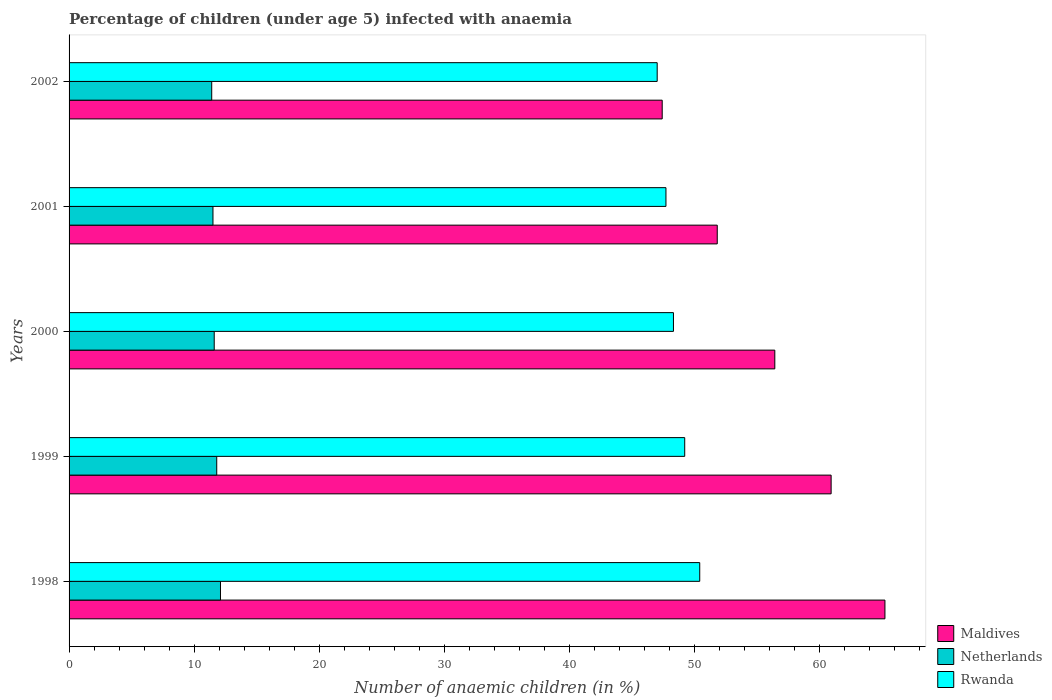How many groups of bars are there?
Your answer should be very brief. 5. How many bars are there on the 1st tick from the bottom?
Make the answer very short. 3. What is the label of the 5th group of bars from the top?
Give a very brief answer. 1998. In how many cases, is the number of bars for a given year not equal to the number of legend labels?
Your response must be concise. 0. Across all years, what is the maximum percentage of children infected with anaemia in in Maldives?
Ensure brevity in your answer.  65.2. Across all years, what is the minimum percentage of children infected with anaemia in in Netherlands?
Your response must be concise. 11.4. In which year was the percentage of children infected with anaemia in in Rwanda minimum?
Ensure brevity in your answer.  2002. What is the total percentage of children infected with anaemia in in Maldives in the graph?
Make the answer very short. 281.7. What is the difference between the percentage of children infected with anaemia in in Maldives in 1998 and that in 1999?
Provide a succinct answer. 4.3. What is the difference between the percentage of children infected with anaemia in in Rwanda in 2000 and the percentage of children infected with anaemia in in Netherlands in 2001?
Offer a very short reply. 36.8. What is the average percentage of children infected with anaemia in in Netherlands per year?
Your response must be concise. 11.68. In the year 1998, what is the difference between the percentage of children infected with anaemia in in Maldives and percentage of children infected with anaemia in in Rwanda?
Provide a succinct answer. 14.8. In how many years, is the percentage of children infected with anaemia in in Rwanda greater than 32 %?
Your response must be concise. 5. What is the ratio of the percentage of children infected with anaemia in in Rwanda in 1998 to that in 2002?
Ensure brevity in your answer.  1.07. What is the difference between the highest and the second highest percentage of children infected with anaemia in in Rwanda?
Keep it short and to the point. 1.2. What is the difference between the highest and the lowest percentage of children infected with anaemia in in Netherlands?
Offer a very short reply. 0.7. In how many years, is the percentage of children infected with anaemia in in Netherlands greater than the average percentage of children infected with anaemia in in Netherlands taken over all years?
Your response must be concise. 2. What does the 3rd bar from the top in 1999 represents?
Offer a terse response. Maldives. What does the 3rd bar from the bottom in 1998 represents?
Provide a short and direct response. Rwanda. How many bars are there?
Make the answer very short. 15. What is the difference between two consecutive major ticks on the X-axis?
Ensure brevity in your answer.  10. Are the values on the major ticks of X-axis written in scientific E-notation?
Your response must be concise. No. Does the graph contain any zero values?
Keep it short and to the point. No. Where does the legend appear in the graph?
Your response must be concise. Bottom right. How are the legend labels stacked?
Make the answer very short. Vertical. What is the title of the graph?
Offer a terse response. Percentage of children (under age 5) infected with anaemia. Does "Mauritania" appear as one of the legend labels in the graph?
Your answer should be very brief. No. What is the label or title of the X-axis?
Your answer should be compact. Number of anaemic children (in %). What is the Number of anaemic children (in %) in Maldives in 1998?
Offer a very short reply. 65.2. What is the Number of anaemic children (in %) in Netherlands in 1998?
Ensure brevity in your answer.  12.1. What is the Number of anaemic children (in %) of Rwanda in 1998?
Your response must be concise. 50.4. What is the Number of anaemic children (in %) in Maldives in 1999?
Your answer should be compact. 60.9. What is the Number of anaemic children (in %) of Rwanda in 1999?
Make the answer very short. 49.2. What is the Number of anaemic children (in %) in Maldives in 2000?
Offer a terse response. 56.4. What is the Number of anaemic children (in %) of Rwanda in 2000?
Your answer should be compact. 48.3. What is the Number of anaemic children (in %) of Maldives in 2001?
Your response must be concise. 51.8. What is the Number of anaemic children (in %) in Netherlands in 2001?
Provide a short and direct response. 11.5. What is the Number of anaemic children (in %) of Rwanda in 2001?
Give a very brief answer. 47.7. What is the Number of anaemic children (in %) in Maldives in 2002?
Ensure brevity in your answer.  47.4. What is the Number of anaemic children (in %) of Netherlands in 2002?
Your response must be concise. 11.4. Across all years, what is the maximum Number of anaemic children (in %) in Maldives?
Keep it short and to the point. 65.2. Across all years, what is the maximum Number of anaemic children (in %) in Netherlands?
Provide a short and direct response. 12.1. Across all years, what is the maximum Number of anaemic children (in %) of Rwanda?
Offer a terse response. 50.4. Across all years, what is the minimum Number of anaemic children (in %) of Maldives?
Keep it short and to the point. 47.4. What is the total Number of anaemic children (in %) in Maldives in the graph?
Give a very brief answer. 281.7. What is the total Number of anaemic children (in %) of Netherlands in the graph?
Give a very brief answer. 58.4. What is the total Number of anaemic children (in %) of Rwanda in the graph?
Your response must be concise. 242.6. What is the difference between the Number of anaemic children (in %) of Netherlands in 1998 and that in 1999?
Give a very brief answer. 0.3. What is the difference between the Number of anaemic children (in %) in Maldives in 1998 and that in 2001?
Ensure brevity in your answer.  13.4. What is the difference between the Number of anaemic children (in %) in Netherlands in 1998 and that in 2002?
Make the answer very short. 0.7. What is the difference between the Number of anaemic children (in %) in Maldives in 1999 and that in 2001?
Your answer should be very brief. 9.1. What is the difference between the Number of anaemic children (in %) of Netherlands in 1999 and that in 2001?
Make the answer very short. 0.3. What is the difference between the Number of anaemic children (in %) of Maldives in 1999 and that in 2002?
Your answer should be compact. 13.5. What is the difference between the Number of anaemic children (in %) in Netherlands in 2000 and that in 2001?
Give a very brief answer. 0.1. What is the difference between the Number of anaemic children (in %) of Maldives in 2000 and that in 2002?
Give a very brief answer. 9. What is the difference between the Number of anaemic children (in %) of Netherlands in 2000 and that in 2002?
Keep it short and to the point. 0.2. What is the difference between the Number of anaemic children (in %) of Rwanda in 2000 and that in 2002?
Your response must be concise. 1.3. What is the difference between the Number of anaemic children (in %) of Maldives in 2001 and that in 2002?
Your answer should be very brief. 4.4. What is the difference between the Number of anaemic children (in %) of Rwanda in 2001 and that in 2002?
Offer a terse response. 0.7. What is the difference between the Number of anaemic children (in %) of Maldives in 1998 and the Number of anaemic children (in %) of Netherlands in 1999?
Your answer should be compact. 53.4. What is the difference between the Number of anaemic children (in %) in Netherlands in 1998 and the Number of anaemic children (in %) in Rwanda in 1999?
Your answer should be very brief. -37.1. What is the difference between the Number of anaemic children (in %) of Maldives in 1998 and the Number of anaemic children (in %) of Netherlands in 2000?
Give a very brief answer. 53.6. What is the difference between the Number of anaemic children (in %) in Netherlands in 1998 and the Number of anaemic children (in %) in Rwanda in 2000?
Your response must be concise. -36.2. What is the difference between the Number of anaemic children (in %) of Maldives in 1998 and the Number of anaemic children (in %) of Netherlands in 2001?
Give a very brief answer. 53.7. What is the difference between the Number of anaemic children (in %) in Netherlands in 1998 and the Number of anaemic children (in %) in Rwanda in 2001?
Offer a terse response. -35.6. What is the difference between the Number of anaemic children (in %) in Maldives in 1998 and the Number of anaemic children (in %) in Netherlands in 2002?
Your answer should be very brief. 53.8. What is the difference between the Number of anaemic children (in %) in Maldives in 1998 and the Number of anaemic children (in %) in Rwanda in 2002?
Ensure brevity in your answer.  18.2. What is the difference between the Number of anaemic children (in %) in Netherlands in 1998 and the Number of anaemic children (in %) in Rwanda in 2002?
Offer a terse response. -34.9. What is the difference between the Number of anaemic children (in %) in Maldives in 1999 and the Number of anaemic children (in %) in Netherlands in 2000?
Ensure brevity in your answer.  49.3. What is the difference between the Number of anaemic children (in %) in Maldives in 1999 and the Number of anaemic children (in %) in Rwanda in 2000?
Give a very brief answer. 12.6. What is the difference between the Number of anaemic children (in %) in Netherlands in 1999 and the Number of anaemic children (in %) in Rwanda in 2000?
Provide a short and direct response. -36.5. What is the difference between the Number of anaemic children (in %) in Maldives in 1999 and the Number of anaemic children (in %) in Netherlands in 2001?
Provide a short and direct response. 49.4. What is the difference between the Number of anaemic children (in %) of Netherlands in 1999 and the Number of anaemic children (in %) of Rwanda in 2001?
Provide a succinct answer. -35.9. What is the difference between the Number of anaemic children (in %) in Maldives in 1999 and the Number of anaemic children (in %) in Netherlands in 2002?
Give a very brief answer. 49.5. What is the difference between the Number of anaemic children (in %) in Maldives in 1999 and the Number of anaemic children (in %) in Rwanda in 2002?
Your answer should be compact. 13.9. What is the difference between the Number of anaemic children (in %) in Netherlands in 1999 and the Number of anaemic children (in %) in Rwanda in 2002?
Your response must be concise. -35.2. What is the difference between the Number of anaemic children (in %) in Maldives in 2000 and the Number of anaemic children (in %) in Netherlands in 2001?
Your answer should be compact. 44.9. What is the difference between the Number of anaemic children (in %) in Maldives in 2000 and the Number of anaemic children (in %) in Rwanda in 2001?
Keep it short and to the point. 8.7. What is the difference between the Number of anaemic children (in %) of Netherlands in 2000 and the Number of anaemic children (in %) of Rwanda in 2001?
Offer a very short reply. -36.1. What is the difference between the Number of anaemic children (in %) of Maldives in 2000 and the Number of anaemic children (in %) of Rwanda in 2002?
Ensure brevity in your answer.  9.4. What is the difference between the Number of anaemic children (in %) of Netherlands in 2000 and the Number of anaemic children (in %) of Rwanda in 2002?
Offer a terse response. -35.4. What is the difference between the Number of anaemic children (in %) of Maldives in 2001 and the Number of anaemic children (in %) of Netherlands in 2002?
Make the answer very short. 40.4. What is the difference between the Number of anaemic children (in %) of Netherlands in 2001 and the Number of anaemic children (in %) of Rwanda in 2002?
Offer a very short reply. -35.5. What is the average Number of anaemic children (in %) of Maldives per year?
Provide a succinct answer. 56.34. What is the average Number of anaemic children (in %) in Netherlands per year?
Provide a succinct answer. 11.68. What is the average Number of anaemic children (in %) of Rwanda per year?
Ensure brevity in your answer.  48.52. In the year 1998, what is the difference between the Number of anaemic children (in %) in Maldives and Number of anaemic children (in %) in Netherlands?
Ensure brevity in your answer.  53.1. In the year 1998, what is the difference between the Number of anaemic children (in %) of Netherlands and Number of anaemic children (in %) of Rwanda?
Keep it short and to the point. -38.3. In the year 1999, what is the difference between the Number of anaemic children (in %) in Maldives and Number of anaemic children (in %) in Netherlands?
Provide a succinct answer. 49.1. In the year 1999, what is the difference between the Number of anaemic children (in %) of Maldives and Number of anaemic children (in %) of Rwanda?
Give a very brief answer. 11.7. In the year 1999, what is the difference between the Number of anaemic children (in %) of Netherlands and Number of anaemic children (in %) of Rwanda?
Provide a succinct answer. -37.4. In the year 2000, what is the difference between the Number of anaemic children (in %) of Maldives and Number of anaemic children (in %) of Netherlands?
Keep it short and to the point. 44.8. In the year 2000, what is the difference between the Number of anaemic children (in %) of Maldives and Number of anaemic children (in %) of Rwanda?
Offer a terse response. 8.1. In the year 2000, what is the difference between the Number of anaemic children (in %) of Netherlands and Number of anaemic children (in %) of Rwanda?
Ensure brevity in your answer.  -36.7. In the year 2001, what is the difference between the Number of anaemic children (in %) in Maldives and Number of anaemic children (in %) in Netherlands?
Give a very brief answer. 40.3. In the year 2001, what is the difference between the Number of anaemic children (in %) of Netherlands and Number of anaemic children (in %) of Rwanda?
Provide a succinct answer. -36.2. In the year 2002, what is the difference between the Number of anaemic children (in %) in Maldives and Number of anaemic children (in %) in Rwanda?
Offer a very short reply. 0.4. In the year 2002, what is the difference between the Number of anaemic children (in %) in Netherlands and Number of anaemic children (in %) in Rwanda?
Make the answer very short. -35.6. What is the ratio of the Number of anaemic children (in %) in Maldives in 1998 to that in 1999?
Provide a short and direct response. 1.07. What is the ratio of the Number of anaemic children (in %) of Netherlands in 1998 to that in 1999?
Offer a terse response. 1.03. What is the ratio of the Number of anaemic children (in %) in Rwanda in 1998 to that in 1999?
Give a very brief answer. 1.02. What is the ratio of the Number of anaemic children (in %) of Maldives in 1998 to that in 2000?
Keep it short and to the point. 1.16. What is the ratio of the Number of anaemic children (in %) of Netherlands in 1998 to that in 2000?
Offer a very short reply. 1.04. What is the ratio of the Number of anaemic children (in %) in Rwanda in 1998 to that in 2000?
Offer a very short reply. 1.04. What is the ratio of the Number of anaemic children (in %) in Maldives in 1998 to that in 2001?
Keep it short and to the point. 1.26. What is the ratio of the Number of anaemic children (in %) of Netherlands in 1998 to that in 2001?
Your answer should be very brief. 1.05. What is the ratio of the Number of anaemic children (in %) in Rwanda in 1998 to that in 2001?
Make the answer very short. 1.06. What is the ratio of the Number of anaemic children (in %) in Maldives in 1998 to that in 2002?
Keep it short and to the point. 1.38. What is the ratio of the Number of anaemic children (in %) in Netherlands in 1998 to that in 2002?
Offer a terse response. 1.06. What is the ratio of the Number of anaemic children (in %) of Rwanda in 1998 to that in 2002?
Give a very brief answer. 1.07. What is the ratio of the Number of anaemic children (in %) in Maldives in 1999 to that in 2000?
Give a very brief answer. 1.08. What is the ratio of the Number of anaemic children (in %) of Netherlands in 1999 to that in 2000?
Offer a very short reply. 1.02. What is the ratio of the Number of anaemic children (in %) in Rwanda in 1999 to that in 2000?
Provide a short and direct response. 1.02. What is the ratio of the Number of anaemic children (in %) of Maldives in 1999 to that in 2001?
Your answer should be very brief. 1.18. What is the ratio of the Number of anaemic children (in %) of Netherlands in 1999 to that in 2001?
Make the answer very short. 1.03. What is the ratio of the Number of anaemic children (in %) in Rwanda in 1999 to that in 2001?
Keep it short and to the point. 1.03. What is the ratio of the Number of anaemic children (in %) of Maldives in 1999 to that in 2002?
Keep it short and to the point. 1.28. What is the ratio of the Number of anaemic children (in %) in Netherlands in 1999 to that in 2002?
Your answer should be compact. 1.04. What is the ratio of the Number of anaemic children (in %) of Rwanda in 1999 to that in 2002?
Offer a terse response. 1.05. What is the ratio of the Number of anaemic children (in %) of Maldives in 2000 to that in 2001?
Your answer should be compact. 1.09. What is the ratio of the Number of anaemic children (in %) in Netherlands in 2000 to that in 2001?
Offer a very short reply. 1.01. What is the ratio of the Number of anaemic children (in %) in Rwanda in 2000 to that in 2001?
Offer a very short reply. 1.01. What is the ratio of the Number of anaemic children (in %) in Maldives in 2000 to that in 2002?
Provide a short and direct response. 1.19. What is the ratio of the Number of anaemic children (in %) in Netherlands in 2000 to that in 2002?
Provide a short and direct response. 1.02. What is the ratio of the Number of anaemic children (in %) in Rwanda in 2000 to that in 2002?
Your answer should be very brief. 1.03. What is the ratio of the Number of anaemic children (in %) in Maldives in 2001 to that in 2002?
Make the answer very short. 1.09. What is the ratio of the Number of anaemic children (in %) in Netherlands in 2001 to that in 2002?
Make the answer very short. 1.01. What is the ratio of the Number of anaemic children (in %) of Rwanda in 2001 to that in 2002?
Make the answer very short. 1.01. What is the difference between the highest and the second highest Number of anaemic children (in %) of Netherlands?
Offer a very short reply. 0.3. What is the difference between the highest and the second highest Number of anaemic children (in %) of Rwanda?
Provide a succinct answer. 1.2. What is the difference between the highest and the lowest Number of anaemic children (in %) of Rwanda?
Give a very brief answer. 3.4. 